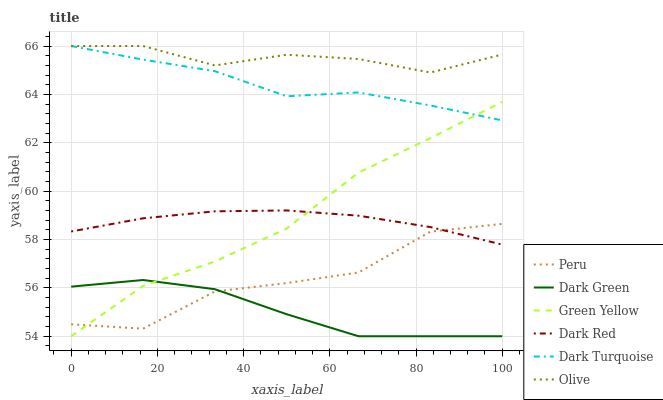Does Dark Green have the minimum area under the curve?
Answer yes or no. Yes. Does Olive have the maximum area under the curve?
Answer yes or no. Yes. Does Peru have the minimum area under the curve?
Answer yes or no. No. Does Peru have the maximum area under the curve?
Answer yes or no. No. Is Dark Red the smoothest?
Answer yes or no. Yes. Is Peru the roughest?
Answer yes or no. Yes. Is Dark Turquoise the smoothest?
Answer yes or no. No. Is Dark Turquoise the roughest?
Answer yes or no. No. Does Green Yellow have the lowest value?
Answer yes or no. Yes. Does Peru have the lowest value?
Answer yes or no. No. Does Olive have the highest value?
Answer yes or no. Yes. Does Peru have the highest value?
Answer yes or no. No. Is Green Yellow less than Olive?
Answer yes or no. Yes. Is Olive greater than Dark Green?
Answer yes or no. Yes. Does Green Yellow intersect Dark Turquoise?
Answer yes or no. Yes. Is Green Yellow less than Dark Turquoise?
Answer yes or no. No. Is Green Yellow greater than Dark Turquoise?
Answer yes or no. No. Does Green Yellow intersect Olive?
Answer yes or no. No. 